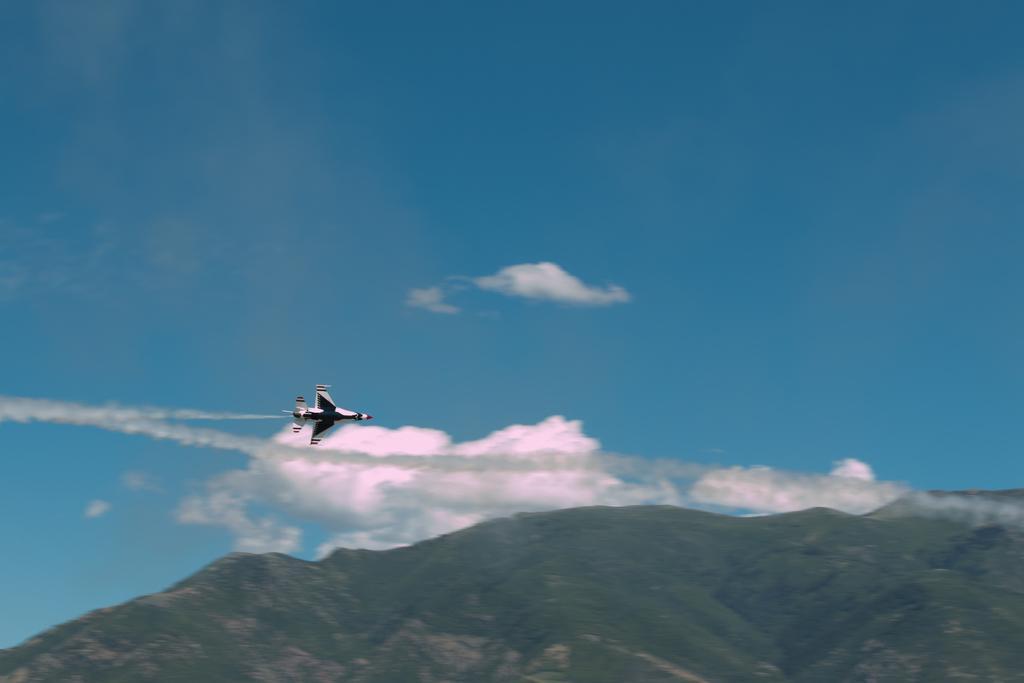How would you summarize this image in a sentence or two? In the center of the image we can see an aeroplane flying in the sky. At the bottom there are hills. In the background there is sky. 